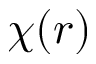<formula> <loc_0><loc_0><loc_500><loc_500>\chi ( r )</formula> 